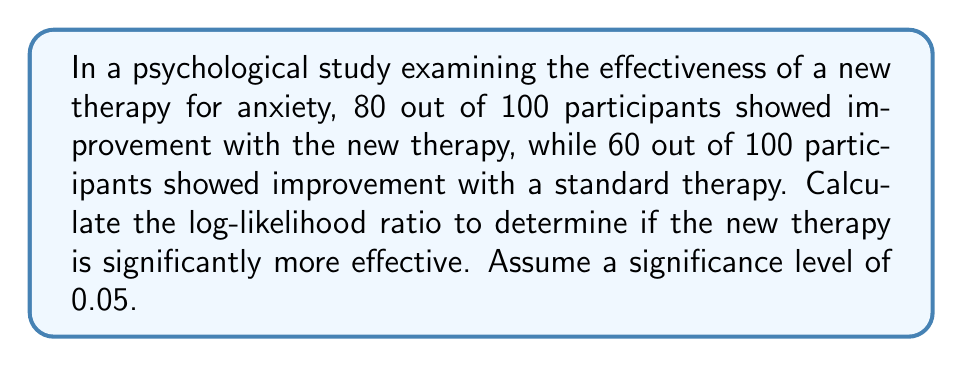What is the answer to this math problem? As a skeptical self-taught psychologist, we'll approach this problem step-by-step using log-likelihood ratios:

1) First, let's define our probabilities:
   $p_1 = 80/100 = 0.8$ (probability of improvement with new therapy)
   $p_2 = 60/100 = 0.6$ (probability of improvement with standard therapy)

2) The log-likelihood ratio (LLR) is calculated as:
   $LLR = 2n[p_1\ln(\frac{p_1}{p_0}) + (1-p_1)\ln(\frac{1-p_1}{1-p_0})]$

   Where $n$ is the sample size (100 in this case) and $p_0$ is the probability under the null hypothesis (we'll use $p_2$ as $p_0$).

3) Let's substitute our values:
   $LLR = 2(100)[0.8\ln(\frac{0.8}{0.6}) + 0.2\ln(\frac{0.2}{0.4})]$

4) Calculate the parts inside the brackets:
   $0.8\ln(\frac{0.8}{0.6}) = 0.8 \cdot 0.2877 = 0.2301$
   $0.2\ln(\frac{0.2}{0.4}) = 0.2 \cdot (-0.6931) = -0.1386$

5) Sum these parts and multiply by 200:
   $LLR = 200(0.2301 - 0.1386) = 200(0.0915) = 18.3$

6) The LLR follows a chi-square distribution with 1 degree of freedom. At a significance level of 0.05, the critical value is 3.841.

7) Since our calculated LLR (18.3) is greater than the critical value (3.841), we reject the null hypothesis.
Answer: $LLR = 18.3$; Significant difference (p < 0.05) 